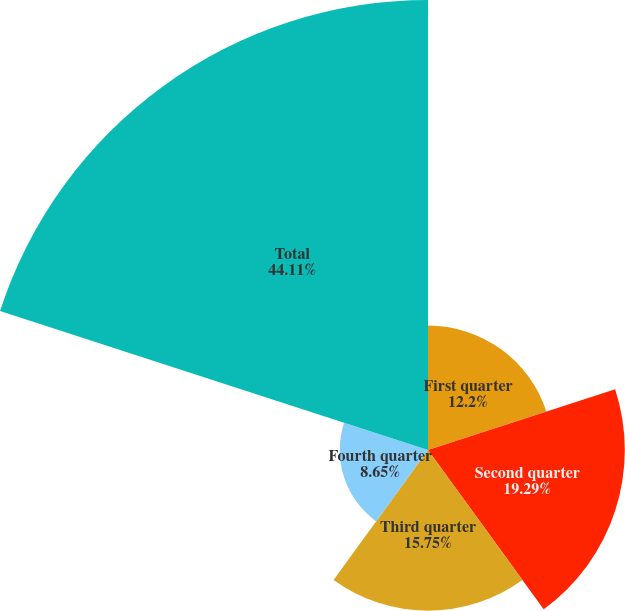<chart> <loc_0><loc_0><loc_500><loc_500><pie_chart><fcel>First quarter<fcel>Second quarter<fcel>Third quarter<fcel>Fourth quarter<fcel>Total<nl><fcel>12.2%<fcel>19.29%<fcel>15.75%<fcel>8.65%<fcel>44.11%<nl></chart> 